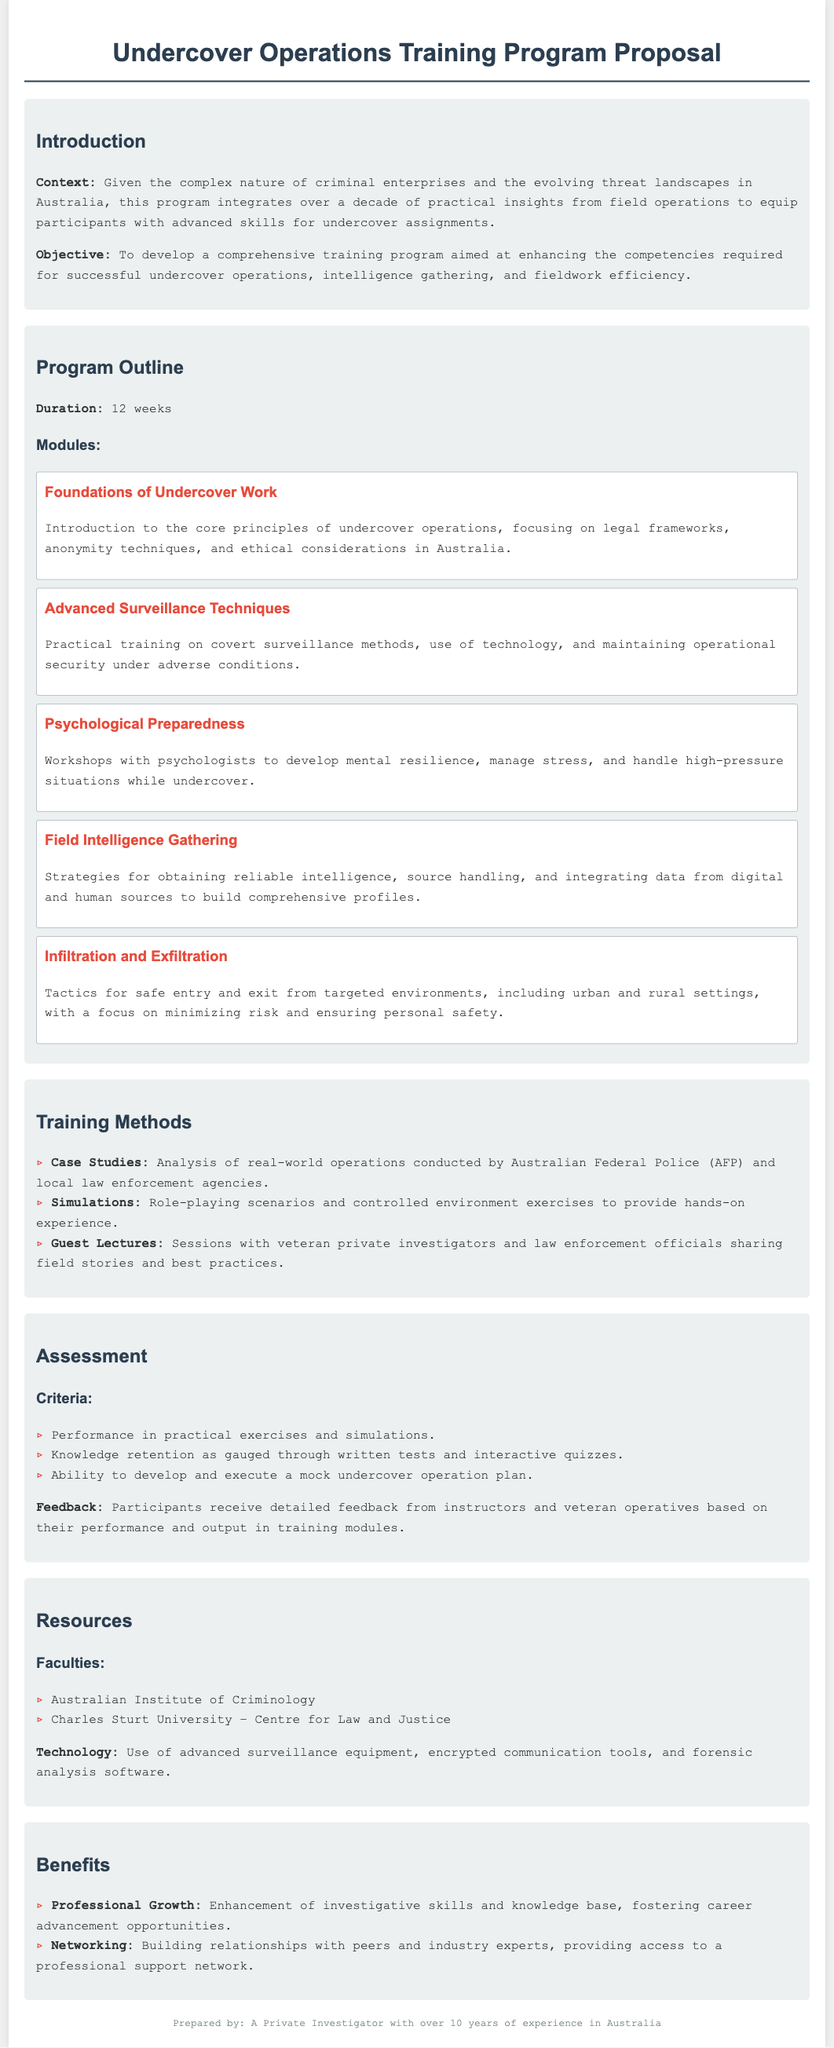What is the duration of the training program? The document states the program duration as 12 weeks.
Answer: 12 weeks What is the focus of the "Foundations of Undercover Work" module? This module introduces core principles of undercover operations, including legal frameworks, anonymity techniques, and ethical considerations in Australia.
Answer: Legal frameworks, anonymity techniques, and ethical considerations Who conducts the psychological preparedness workshops? The document mentions that workshops are conducted with psychologists to develop mental resilience.
Answer: Psychologists What type of assessments are included in the program? The document lists several assessment criteria, including practical exercises, knowledge retention, and mock undercover operation plans.
Answer: Practical exercises, knowledge retention, and mock undercover operation plans Which two faculties are mentioned as resources for the program? The document states that the Australian Institute of Criminology and Charles Sturt University are involved in the program.
Answer: Australian Institute of Criminology and Charles Sturt University What is a key benefit of the training program? The benefits listed include enhancement of investigative skills and career advancement opportunities.
Answer: Enhancement of investigative skills What method involves role-playing scenarios? The document highlights simulations as a method that includes role-playing scenarios for hands-on experience.
Answer: Simulations What color is used for the headings in the document? The headings utilize a specific shade denoted as #2c3e50 in the styling section of the code.
Answer: #2c3e50 